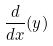Convert formula to latex. <formula><loc_0><loc_0><loc_500><loc_500>\frac { d } { d x } ( y )</formula> 